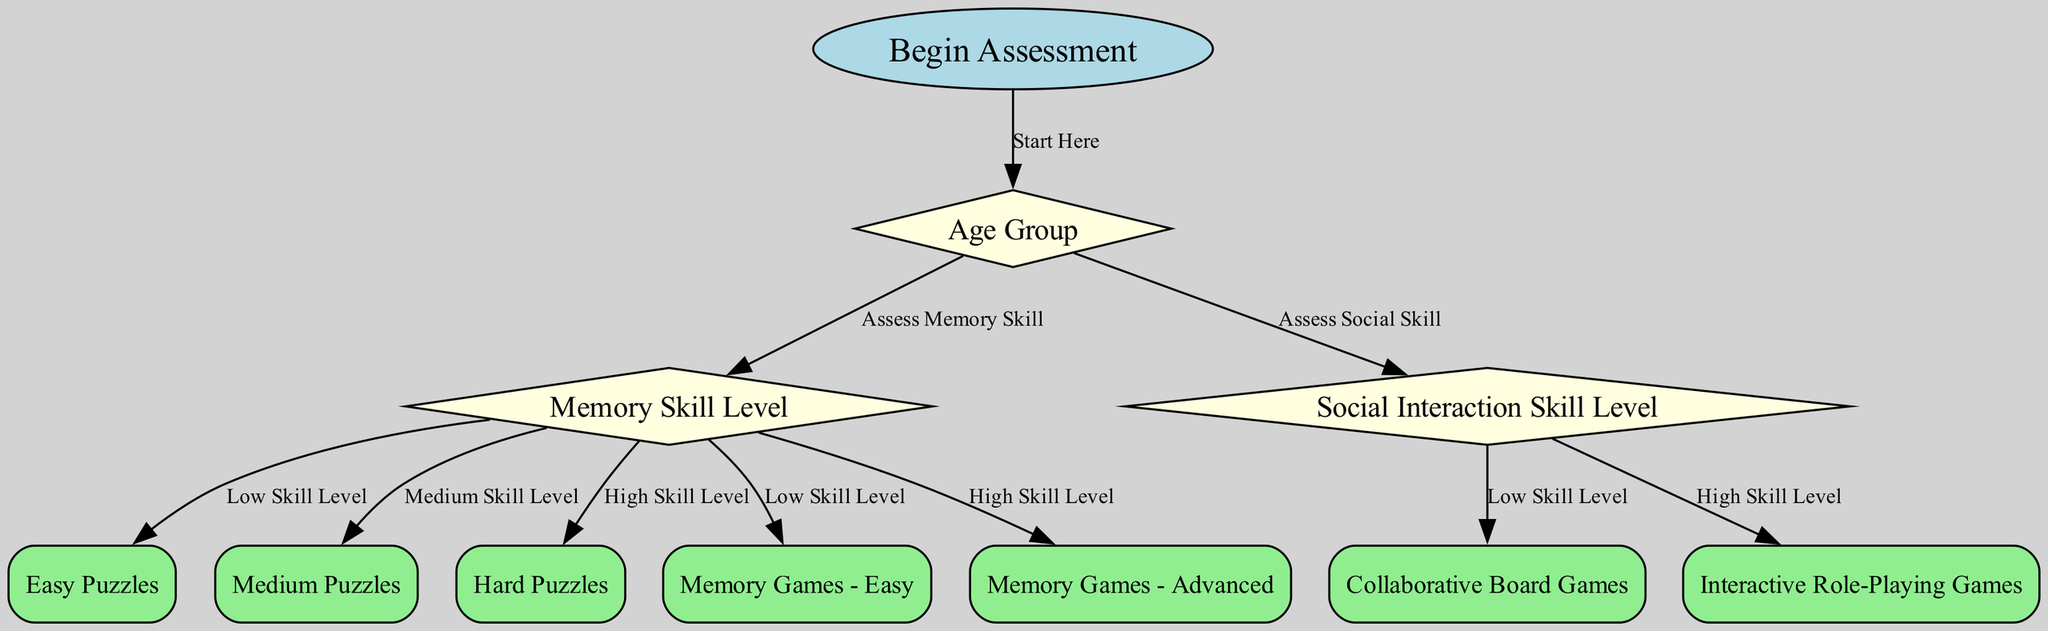What is the first step in the decision tree? The first node in the diagram is labeled "Begin Assessment." This represents the starting point of the decision-making process.
Answer: Begin Assessment How many edges connect the 'age group' node? The 'age group' node has two outgoing edges: one leading to the 'memory skill' node and another to the 'social interaction' node, indicating assessments for both skill levels.
Answer: 2 What games are suggested for high memory skill levels? The node corresponding to high memory skill levels leads to the 'memory games - advanced' node, suggesting this type of game for children with advanced skills.
Answer: Memory Games - Advanced What type of games is recommended for children with low social interaction skills? The 'social interaction' node for low skill level directs to the 'collaborative board games' node, indicating this type of game is appropriate for these children.
Answer: Collaborative Board Games Which node follows the assessment of 'memory skill'? The assessment of 'memory skill' leads to three distinct game options based on differing skill levels: easy puzzles, medium puzzles, and memory games - easy or advanced, indicating a branching decision based on the outcome of the assessment.
Answer: Puzzles Easy, Puzzles Medium, Memory Games - Easy What node represents the final game options for children's skills? Final game options are represented by the nodes following assessments of memory and social skills, specifically recommending various puzzles and games - such as easy puzzles, collaborative board games, or interactive role-playing games - depending on the assessed skill levels.
Answer: Puzzles Easy, Medium, Hard; Board Games; Role-Playing Games If a child is assessed as having high social interaction skill, which node would they be directed to? The decision tree indicates that a child with high social interaction skill would be directed to the 'interactive role-playing games' node, indicating this is the recommended type of game for enhanced social skills.
Answer: Interactive Role-Playing Games For children with low memory skill and low social interaction skills, which games are recommended? Following the diagram's paths, a child who is assessed as having both low memory and social interaction skills would be directed to 'easy puzzles' and possibly 'memory games - easy,' representing simpler game options suitable for these skill levels.
Answer: Easy Puzzles, Memory Games - Easy What is the significance of the diamond-shaped nodes in the diagram? The diamond-shaped nodes denote decision points in the decision tree, where assessments are made regarding the child's skill levels in memory and social interaction, guiding the selection of appropriate games.
Answer: Decision Points 